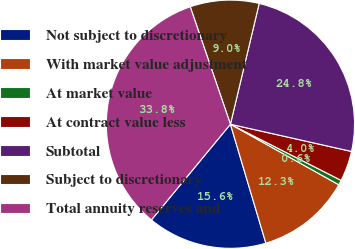<chart> <loc_0><loc_0><loc_500><loc_500><pie_chart><fcel>Not subject to discretionary<fcel>With market value adjustment<fcel>At market value<fcel>At contract value less<fcel>Subtotal<fcel>Subject to discretionary<fcel>Total annuity reserves and<nl><fcel>15.59%<fcel>12.28%<fcel>0.64%<fcel>3.95%<fcel>24.79%<fcel>8.97%<fcel>33.76%<nl></chart> 